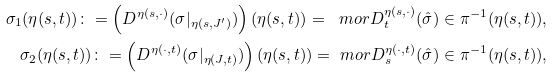<formula> <loc_0><loc_0><loc_500><loc_500>\sigma _ { 1 } ( \eta ( s , t ) ) \colon = \left ( D ^ { \eta ( s , \cdot ) } ( \sigma | _ { \eta ( s , J ^ { \prime } ) } ) \right ) ( \eta ( s , t ) ) = \ m o r { D } _ { t } ^ { \eta ( s , \cdot ) } ( \hat { \sigma } ) \in \pi ^ { - 1 } ( \eta ( s , t ) ) , \\ \sigma _ { 2 } ( \eta ( s , t ) ) \colon = \left ( D ^ { \eta ( \cdot , t ) } ( \sigma | _ { \eta ( J , t ) } ) \right ) ( \eta ( s , t ) ) = \ m o r { D } _ { s } ^ { \eta ( \cdot , t ) } ( \hat { \sigma } ) \in \pi ^ { - 1 } ( \eta ( s , t ) ) ,</formula> 